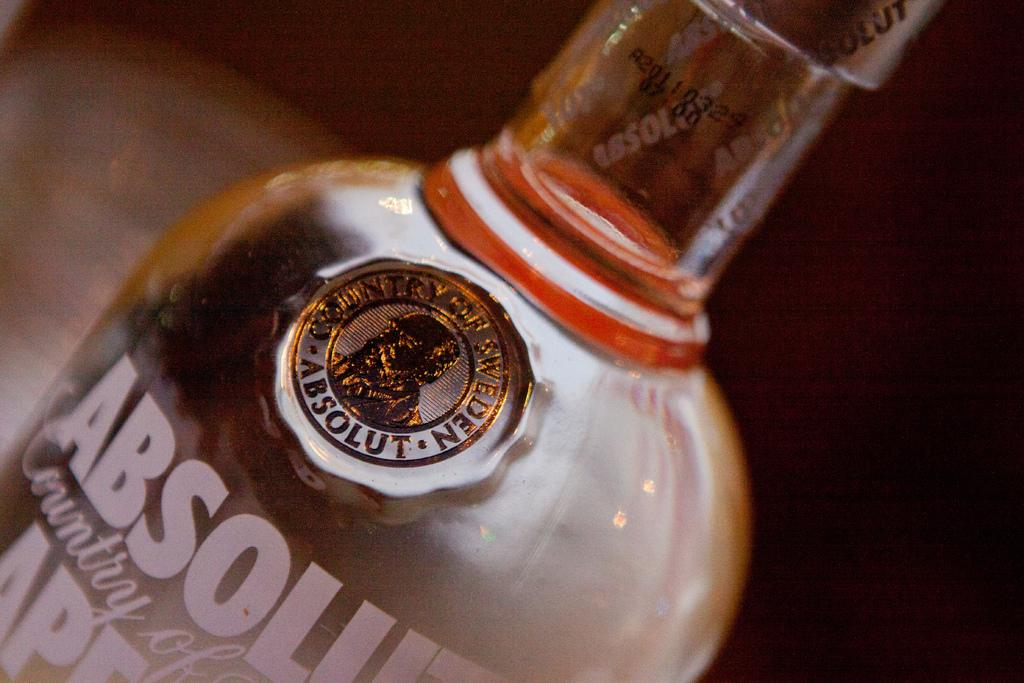<image>
Offer a succinct explanation of the picture presented. A clear Absolut Vodka bottle with the gold Absolute medallion on it. 